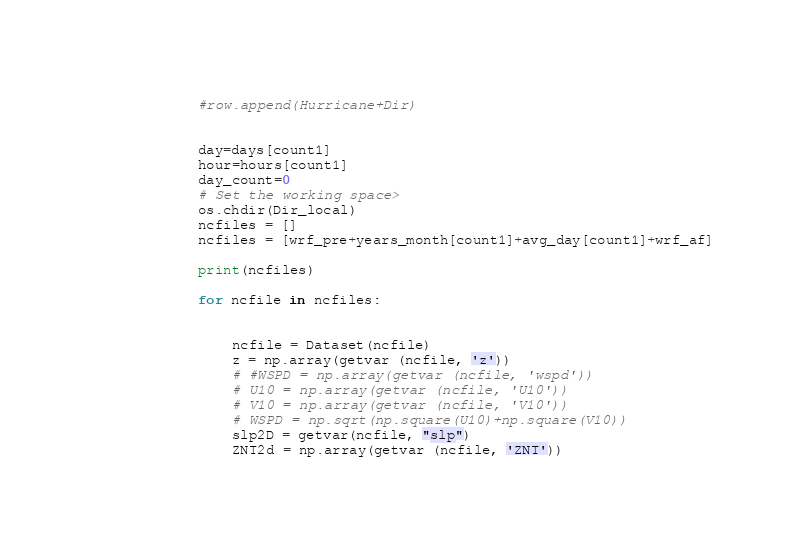<code> <loc_0><loc_0><loc_500><loc_500><_Python_>            #row.append(Hurricane+Dir)
             
            
            day=days[count1]
            hour=hours[count1]
            day_count=0
            # Set the working space>
            os.chdir(Dir_local)
            ncfiles = []
            ncfiles = [wrf_pre+years_month[count1]+avg_day[count1]+wrf_af]

            print(ncfiles)

            for ncfile in ncfiles:  
    

     	        ncfile = Dataset(ncfile)
     	        z = np.array(getvar (ncfile, 'z'))
     	        # #WSPD = np.array(getvar (ncfile, 'wspd'))
     	        # U10 = np.array(getvar (ncfile, 'U10'))
     	        # V10 = np.array(getvar (ncfile, 'V10'))
     	        # WSPD = np.sqrt(np.square(U10)+np.square(V10))
     	        slp2D = getvar(ncfile, "slp")
     	        ZNT2d = np.array(getvar (ncfile, 'ZNT'))</code> 